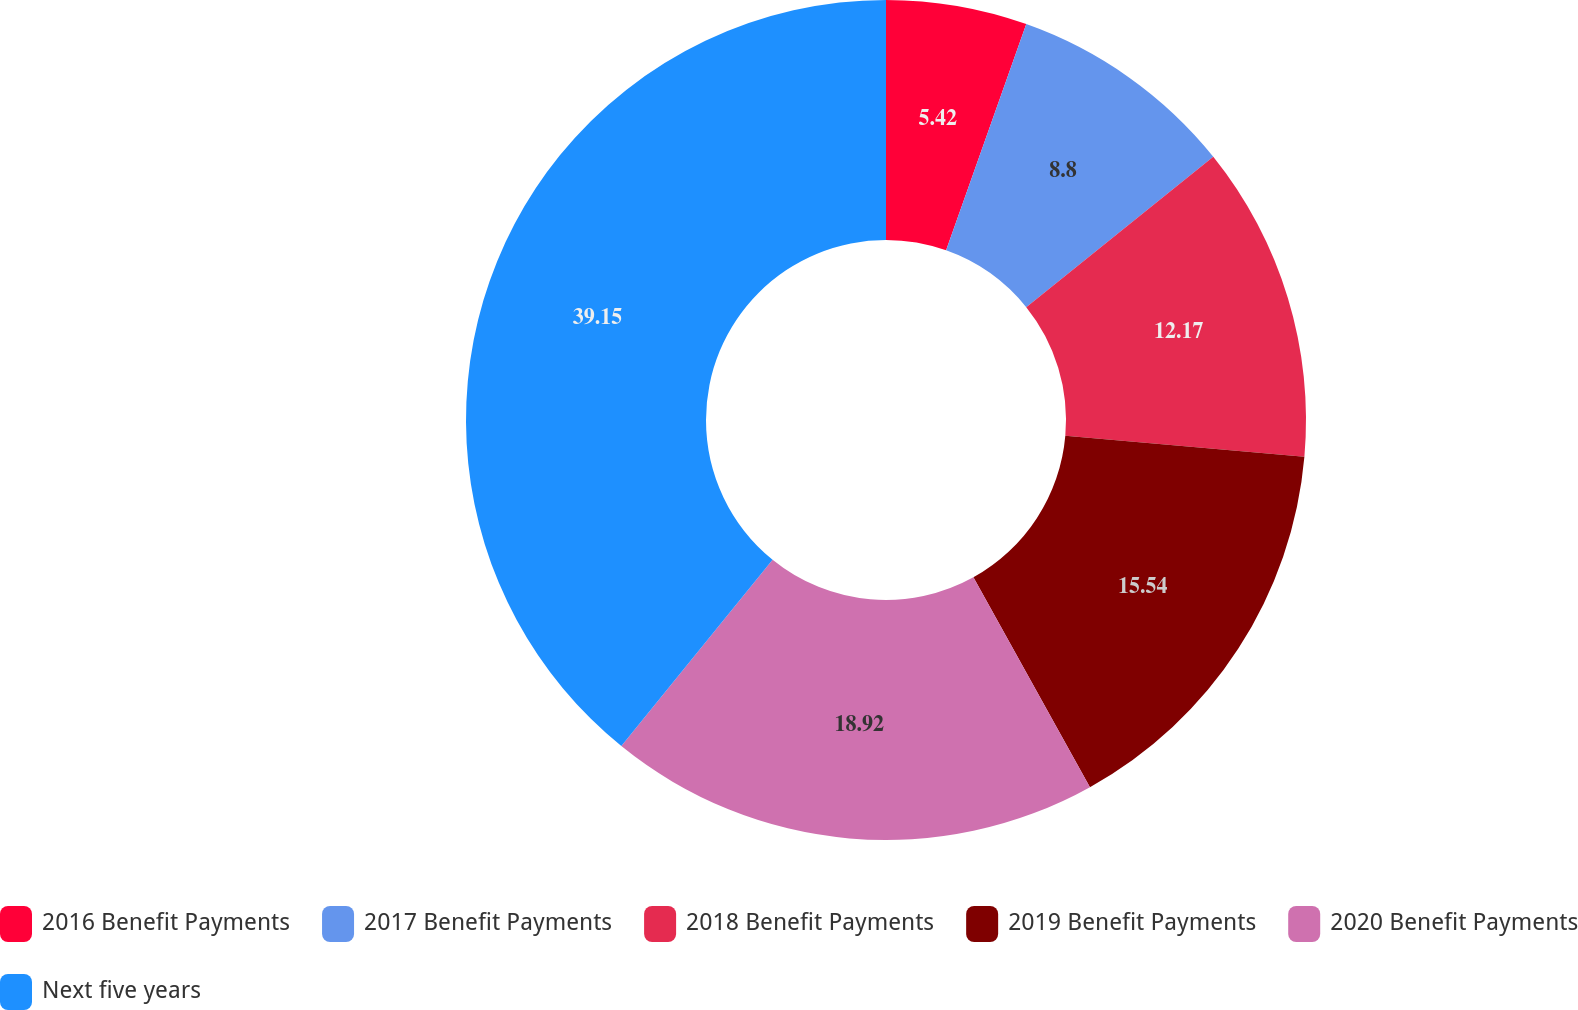<chart> <loc_0><loc_0><loc_500><loc_500><pie_chart><fcel>2016 Benefit Payments<fcel>2017 Benefit Payments<fcel>2018 Benefit Payments<fcel>2019 Benefit Payments<fcel>2020 Benefit Payments<fcel>Next five years<nl><fcel>5.42%<fcel>8.8%<fcel>12.17%<fcel>15.54%<fcel>18.92%<fcel>39.15%<nl></chart> 